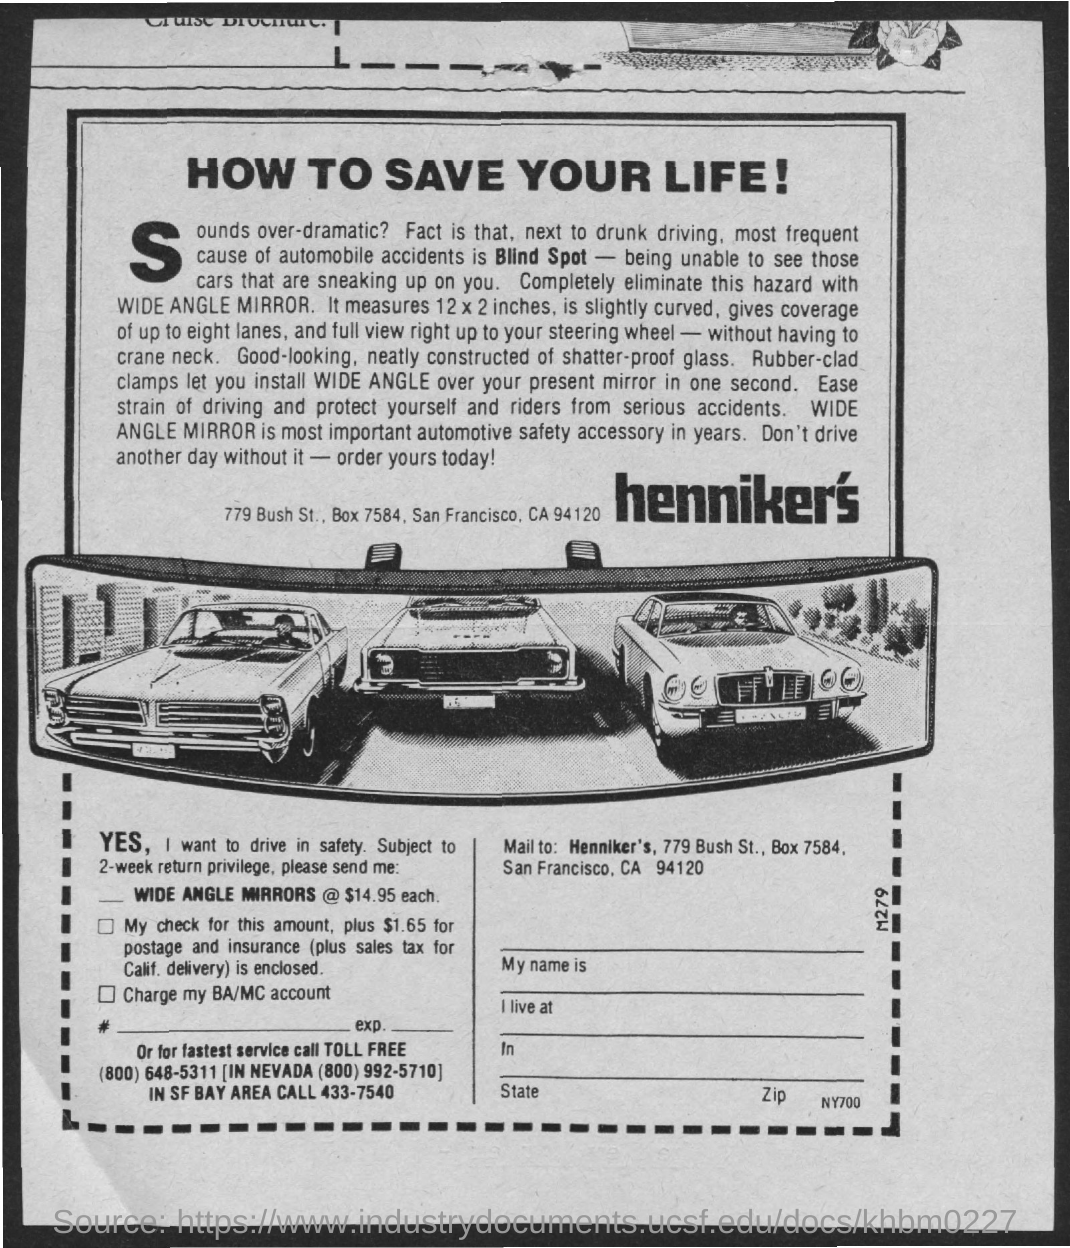Specify some key components in this picture. The blind spot is the most common cause of automobile accidents. 